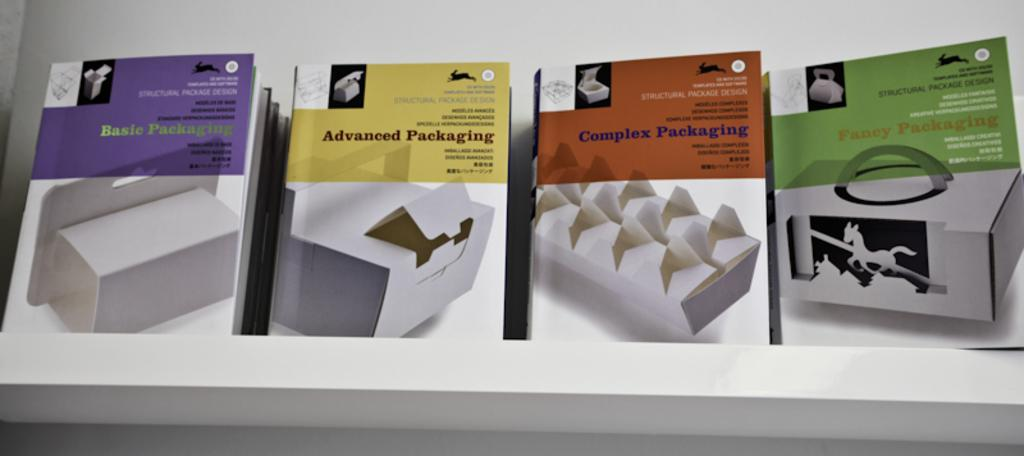Provide a one-sentence caption for the provided image. four different packages with one labeled 'adavanced packaging'. 